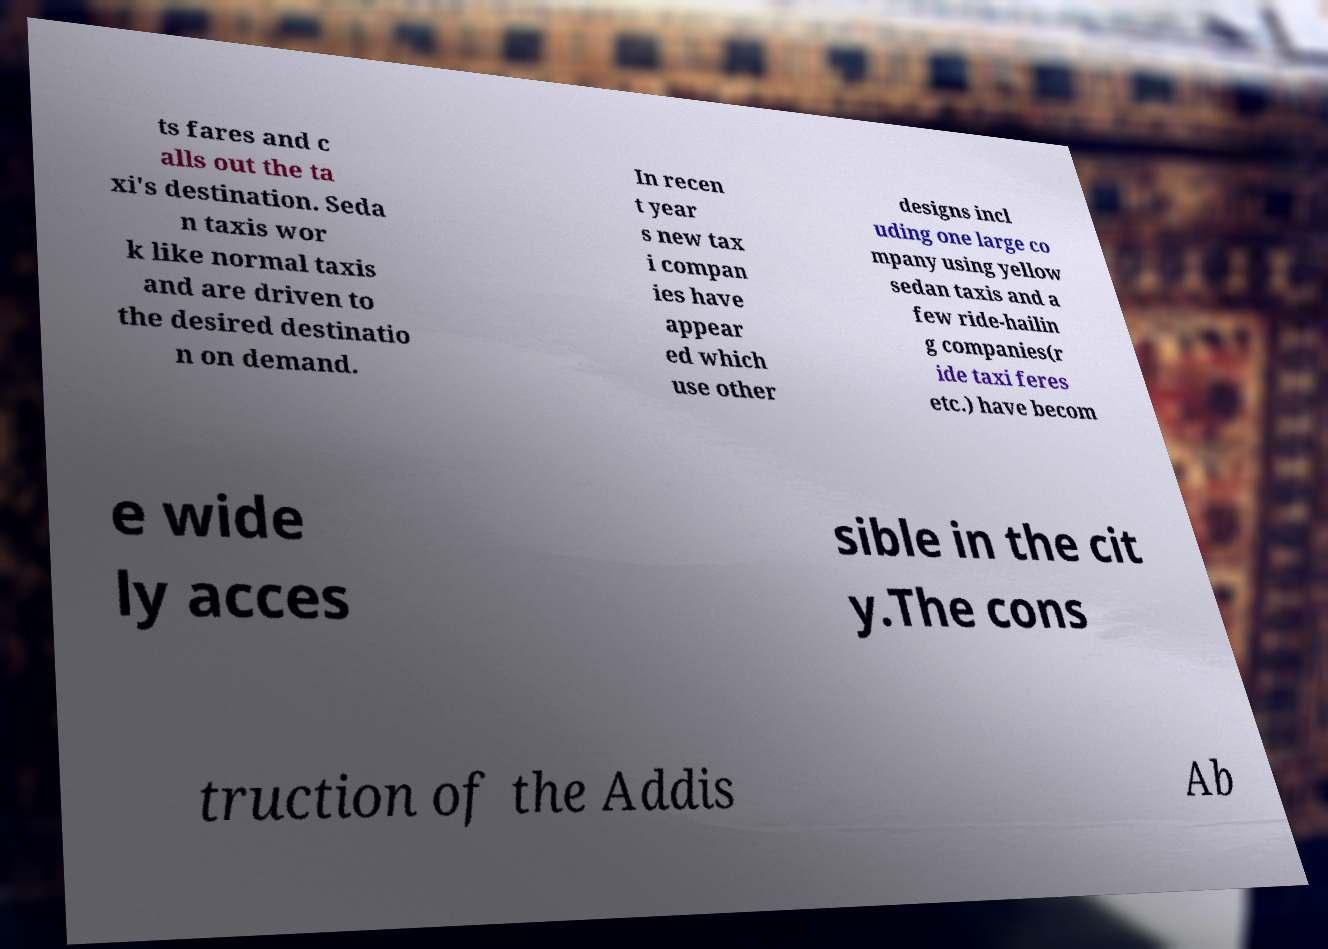I need the written content from this picture converted into text. Can you do that? ts fares and c alls out the ta xi's destination. Seda n taxis wor k like normal taxis and are driven to the desired destinatio n on demand. In recen t year s new tax i compan ies have appear ed which use other designs incl uding one large co mpany using yellow sedan taxis and a few ride-hailin g companies(r ide taxi feres etc.) have becom e wide ly acces sible in the cit y.The cons truction of the Addis Ab 